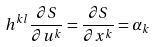Convert formula to latex. <formula><loc_0><loc_0><loc_500><loc_500>h ^ { k l } \frac { \partial S } { \partial u ^ { k } } = \frac { \partial S } { \partial x ^ { k } } = \alpha _ { k }</formula> 